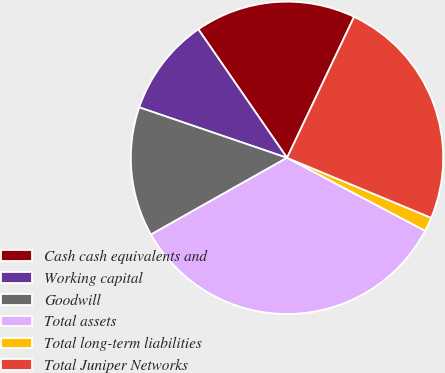Convert chart to OTSL. <chart><loc_0><loc_0><loc_500><loc_500><pie_chart><fcel>Cash cash equivalents and<fcel>Working capital<fcel>Goodwill<fcel>Total assets<fcel>Total long-term liabilities<fcel>Total Juniper Networks<nl><fcel>16.68%<fcel>10.15%<fcel>13.41%<fcel>34.09%<fcel>1.46%<fcel>24.21%<nl></chart> 